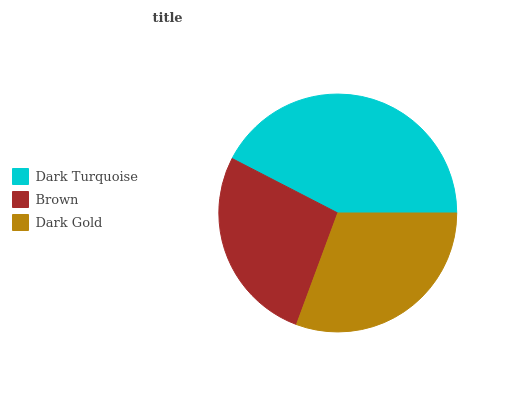Is Brown the minimum?
Answer yes or no. Yes. Is Dark Turquoise the maximum?
Answer yes or no. Yes. Is Dark Gold the minimum?
Answer yes or no. No. Is Dark Gold the maximum?
Answer yes or no. No. Is Dark Gold greater than Brown?
Answer yes or no. Yes. Is Brown less than Dark Gold?
Answer yes or no. Yes. Is Brown greater than Dark Gold?
Answer yes or no. No. Is Dark Gold less than Brown?
Answer yes or no. No. Is Dark Gold the high median?
Answer yes or no. Yes. Is Dark Gold the low median?
Answer yes or no. Yes. Is Brown the high median?
Answer yes or no. No. Is Dark Turquoise the low median?
Answer yes or no. No. 